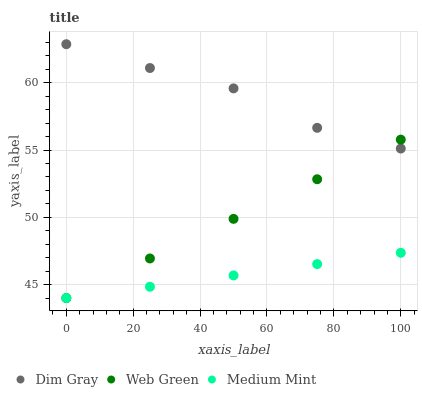Does Medium Mint have the minimum area under the curve?
Answer yes or no. Yes. Does Dim Gray have the maximum area under the curve?
Answer yes or no. Yes. Does Web Green have the minimum area under the curve?
Answer yes or no. No. Does Web Green have the maximum area under the curve?
Answer yes or no. No. Is Medium Mint the smoothest?
Answer yes or no. Yes. Is Dim Gray the roughest?
Answer yes or no. Yes. Is Web Green the smoothest?
Answer yes or no. No. Is Web Green the roughest?
Answer yes or no. No. Does Medium Mint have the lowest value?
Answer yes or no. Yes. Does Dim Gray have the lowest value?
Answer yes or no. No. Does Dim Gray have the highest value?
Answer yes or no. Yes. Does Web Green have the highest value?
Answer yes or no. No. Is Medium Mint less than Dim Gray?
Answer yes or no. Yes. Is Dim Gray greater than Medium Mint?
Answer yes or no. Yes. Does Dim Gray intersect Web Green?
Answer yes or no. Yes. Is Dim Gray less than Web Green?
Answer yes or no. No. Is Dim Gray greater than Web Green?
Answer yes or no. No. Does Medium Mint intersect Dim Gray?
Answer yes or no. No. 